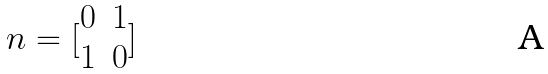<formula> <loc_0><loc_0><loc_500><loc_500>n = [ \begin{matrix} 0 & 1 \\ 1 & 0 \end{matrix} ]</formula> 